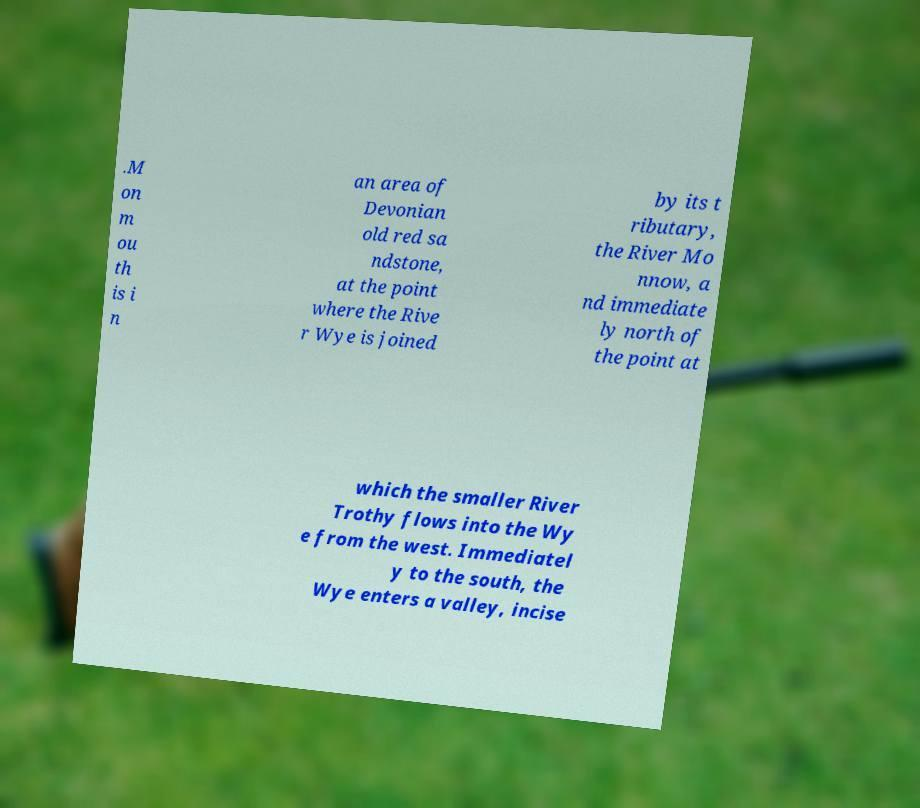Could you assist in decoding the text presented in this image and type it out clearly? .M on m ou th is i n an area of Devonian old red sa ndstone, at the point where the Rive r Wye is joined by its t ributary, the River Mo nnow, a nd immediate ly north of the point at which the smaller River Trothy flows into the Wy e from the west. Immediatel y to the south, the Wye enters a valley, incise 